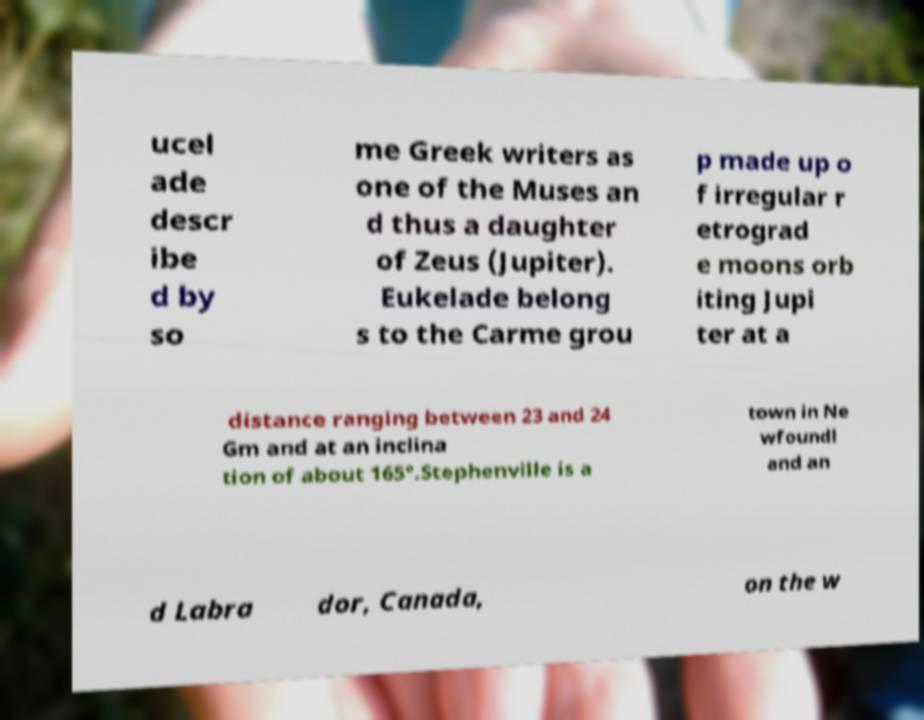What messages or text are displayed in this image? I need them in a readable, typed format. ucel ade descr ibe d by so me Greek writers as one of the Muses an d thus a daughter of Zeus (Jupiter). Eukelade belong s to the Carme grou p made up o f irregular r etrograd e moons orb iting Jupi ter at a distance ranging between 23 and 24 Gm and at an inclina tion of about 165°.Stephenville is a town in Ne wfoundl and an d Labra dor, Canada, on the w 